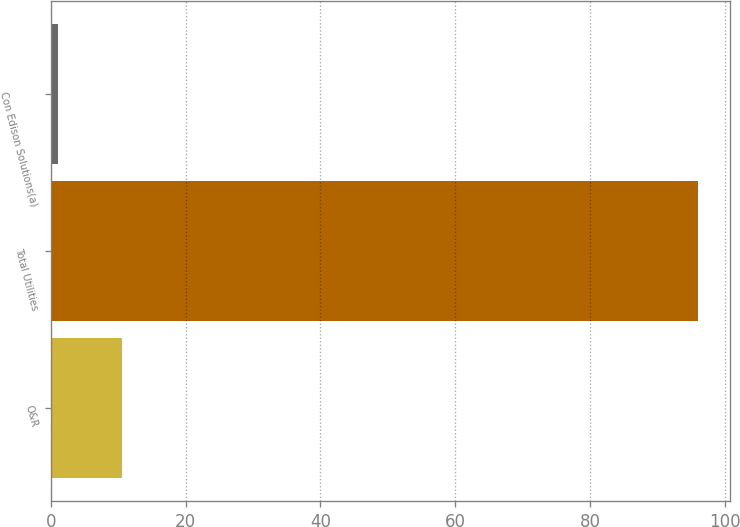Convert chart to OTSL. <chart><loc_0><loc_0><loc_500><loc_500><bar_chart><fcel>O&R<fcel>Total Utilities<fcel>Con Edison Solutions(a)<nl><fcel>10.5<fcel>96<fcel>1<nl></chart> 